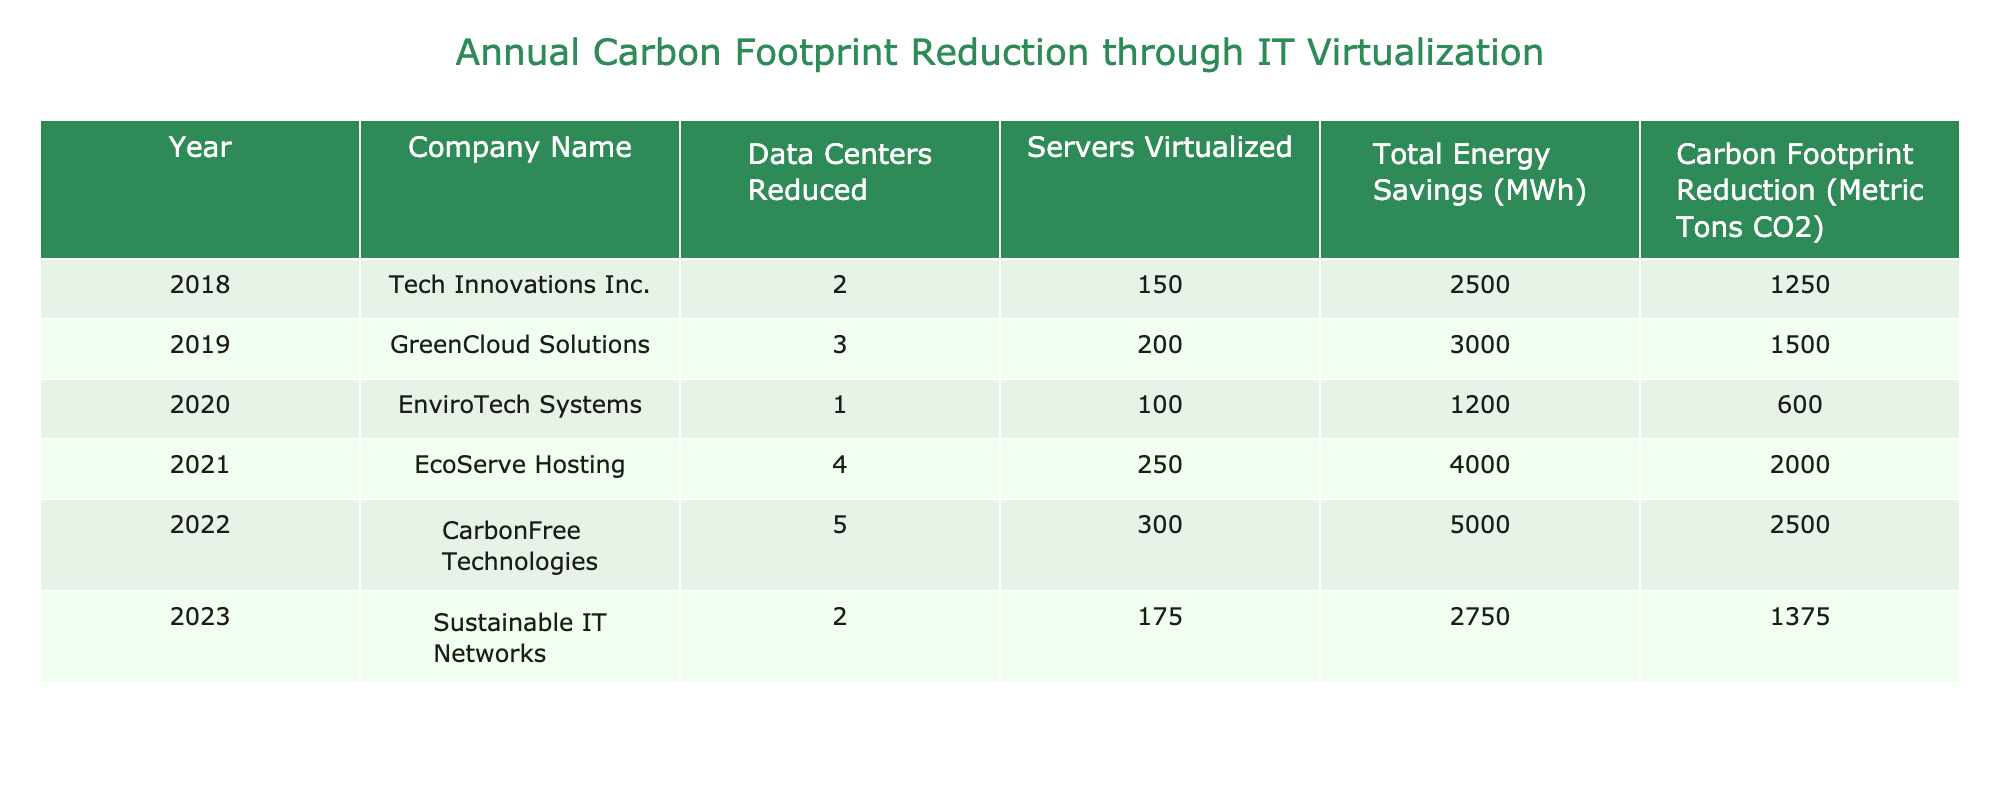What was the highest carbon footprint reduction achieved in a single year? The table shows annual carbon footprint reductions for each company from 2018 to 2023. The highest value is 2500 metric tons CO2 from CarbonFree Technologies in 2022.
Answer: 2500 Which company had the most data centers reduced in a single year? Reviewing the table, CarbonFree Technologies had the most data centers reduced, with a value of 5 in 2022.
Answer: 5 How many servers were virtualized by EcoServe Hosting? According to the table, EcoServe Hosting virtualized 250 servers in 2021.
Answer: 250 What is the total carbon footprint reduction from 2018 to 2020? To find the total, sum the carbon footprint reductions from 2018 (1250), 2019 (1500), and 2020 (600), which gives a total of 1250 + 1500 + 600 = 3350 metric tons CO2.
Answer: 3350 Did Sustainable IT Networks reduce their carbon footprint more than Tech Innovations Inc.? Sustainable IT Networks reduced their carbon footprint by 1375 metric tons CO2 in 2023 while Tech Innovations Inc. reduced it by 1250 metric tons CO2 in 2018. Thus, yes, they reduced more.
Answer: Yes What is the average carbon footprint reduction achieved across all the years in the table? To calculate the average, sum all carbon footprint reductions: 1250 + 1500 + 600 + 2000 + 2500 + 1375 = 10225. Then divide by the number of years, which is 6. Thus, 10225 / 6 = 1704.17 metric tons CO2.
Answer: 1704.17 Which year saw the least reduction in carbon footprint? Looking closely at the data, 2020 saw the least carbon footprint reduction of 600 metric tons CO2 by EnviroTech Systems.
Answer: 600 Compare the total energy savings between 2018 and 2023. Which year had higher savings? In 2018, total energy savings were 2500 MWh, and in 2023, they were 2750 MWh. Comparing these values shows that 2023 had higher energy savings.
Answer: 2023 How many total servers were virtualized from 2019 to 2021? By summing the servers virtualized from 2019 (200), 2020 (100), and 2021 (250), we get 200 + 100 + 250 = 550 servers virtualized from 2019 to 2021.
Answer: 550 